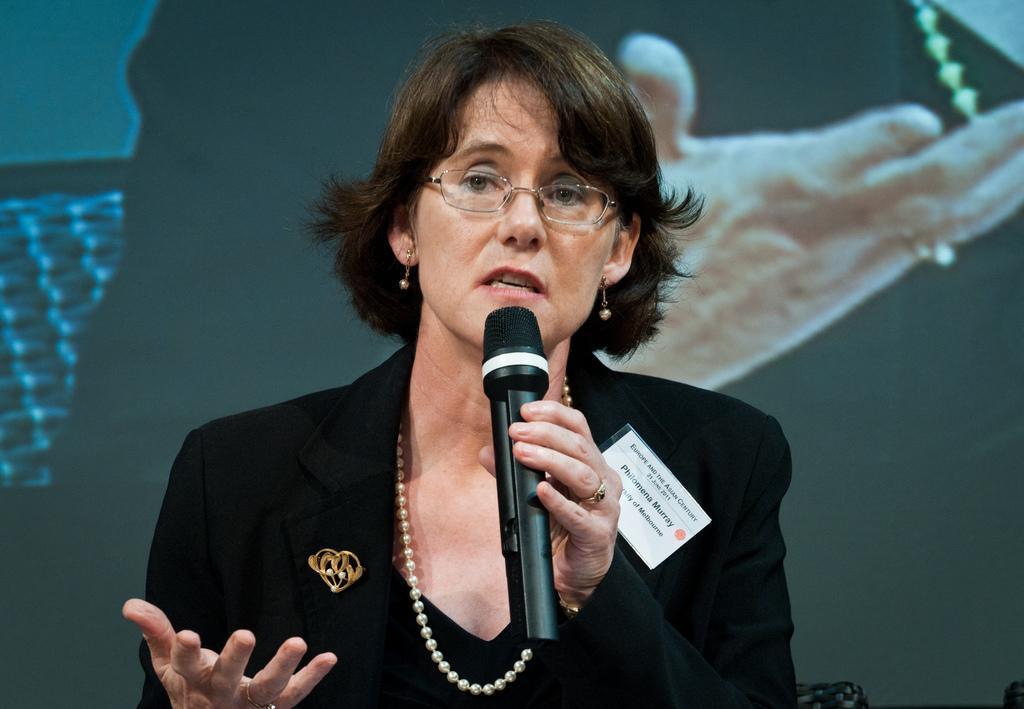Please provide a concise description of this image. A woman is speaking in the microphone. She wear a black coat. 